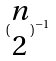<formula> <loc_0><loc_0><loc_500><loc_500>( \begin{matrix} n \\ 2 \end{matrix} ) ^ { - 1 }</formula> 